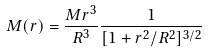Convert formula to latex. <formula><loc_0><loc_0><loc_500><loc_500>M ( r ) = \frac { M r ^ { 3 } } { R ^ { 3 } } \frac { 1 } { [ 1 + r ^ { 2 } / R ^ { 2 } ] ^ { 3 / 2 } }</formula> 